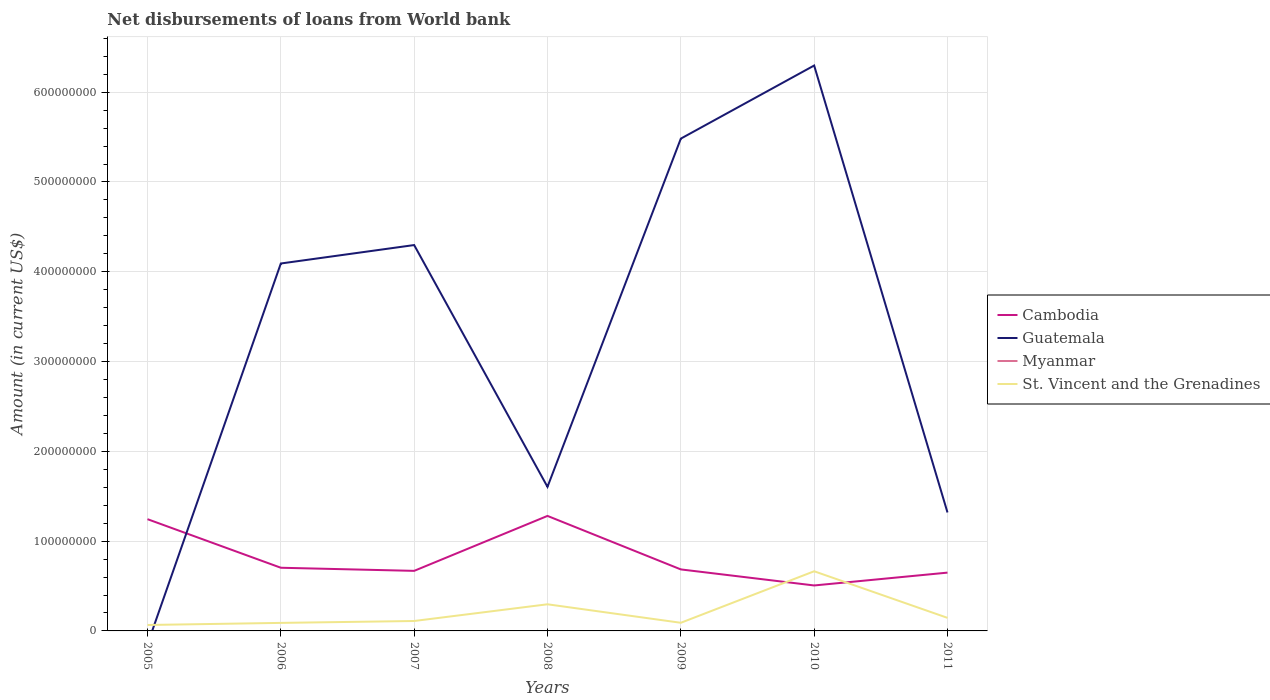How many different coloured lines are there?
Provide a short and direct response. 3. Does the line corresponding to Guatemala intersect with the line corresponding to Myanmar?
Provide a succinct answer. Yes. Across all years, what is the maximum amount of loan disbursed from World Bank in Guatemala?
Keep it short and to the point. 0. What is the total amount of loan disbursed from World Bank in Cambodia in the graph?
Provide a succinct answer. 5.95e+07. What is the difference between the highest and the second highest amount of loan disbursed from World Bank in Cambodia?
Your response must be concise. 7.75e+07. What is the difference between the highest and the lowest amount of loan disbursed from World Bank in St. Vincent and the Grenadines?
Your response must be concise. 2. Is the amount of loan disbursed from World Bank in Cambodia strictly greater than the amount of loan disbursed from World Bank in Myanmar over the years?
Your answer should be very brief. No. How many lines are there?
Your response must be concise. 3. How many years are there in the graph?
Your answer should be compact. 7. What is the difference between two consecutive major ticks on the Y-axis?
Offer a terse response. 1.00e+08. Are the values on the major ticks of Y-axis written in scientific E-notation?
Your response must be concise. No. Does the graph contain any zero values?
Offer a terse response. Yes. How many legend labels are there?
Make the answer very short. 4. What is the title of the graph?
Your answer should be very brief. Net disbursements of loans from World bank. What is the label or title of the Y-axis?
Your answer should be compact. Amount (in current US$). What is the Amount (in current US$) of Cambodia in 2005?
Give a very brief answer. 1.24e+08. What is the Amount (in current US$) in St. Vincent and the Grenadines in 2005?
Provide a short and direct response. 6.60e+06. What is the Amount (in current US$) of Cambodia in 2006?
Keep it short and to the point. 7.04e+07. What is the Amount (in current US$) in Guatemala in 2006?
Provide a short and direct response. 4.09e+08. What is the Amount (in current US$) of St. Vincent and the Grenadines in 2006?
Offer a very short reply. 8.95e+06. What is the Amount (in current US$) of Cambodia in 2007?
Give a very brief answer. 6.69e+07. What is the Amount (in current US$) in Guatemala in 2007?
Provide a succinct answer. 4.30e+08. What is the Amount (in current US$) in St. Vincent and the Grenadines in 2007?
Your response must be concise. 1.10e+07. What is the Amount (in current US$) in Cambodia in 2008?
Keep it short and to the point. 1.28e+08. What is the Amount (in current US$) of Guatemala in 2008?
Provide a succinct answer. 1.60e+08. What is the Amount (in current US$) of St. Vincent and the Grenadines in 2008?
Provide a short and direct response. 2.97e+07. What is the Amount (in current US$) of Cambodia in 2009?
Offer a very short reply. 6.85e+07. What is the Amount (in current US$) of Guatemala in 2009?
Keep it short and to the point. 5.48e+08. What is the Amount (in current US$) in St. Vincent and the Grenadines in 2009?
Provide a short and direct response. 9.07e+06. What is the Amount (in current US$) of Cambodia in 2010?
Your answer should be compact. 5.06e+07. What is the Amount (in current US$) of Guatemala in 2010?
Your answer should be compact. 6.30e+08. What is the Amount (in current US$) of St. Vincent and the Grenadines in 2010?
Give a very brief answer. 6.64e+07. What is the Amount (in current US$) of Cambodia in 2011?
Offer a terse response. 6.49e+07. What is the Amount (in current US$) in Guatemala in 2011?
Make the answer very short. 1.32e+08. What is the Amount (in current US$) of Myanmar in 2011?
Make the answer very short. 0. What is the Amount (in current US$) in St. Vincent and the Grenadines in 2011?
Provide a short and direct response. 1.46e+07. Across all years, what is the maximum Amount (in current US$) in Cambodia?
Provide a succinct answer. 1.28e+08. Across all years, what is the maximum Amount (in current US$) in Guatemala?
Ensure brevity in your answer.  6.30e+08. Across all years, what is the maximum Amount (in current US$) of St. Vincent and the Grenadines?
Ensure brevity in your answer.  6.64e+07. Across all years, what is the minimum Amount (in current US$) of Cambodia?
Give a very brief answer. 5.06e+07. Across all years, what is the minimum Amount (in current US$) in Guatemala?
Provide a short and direct response. 0. Across all years, what is the minimum Amount (in current US$) in St. Vincent and the Grenadines?
Your response must be concise. 6.60e+06. What is the total Amount (in current US$) of Cambodia in the graph?
Ensure brevity in your answer.  5.74e+08. What is the total Amount (in current US$) in Guatemala in the graph?
Make the answer very short. 2.31e+09. What is the total Amount (in current US$) in Myanmar in the graph?
Make the answer very short. 0. What is the total Amount (in current US$) in St. Vincent and the Grenadines in the graph?
Ensure brevity in your answer.  1.46e+08. What is the difference between the Amount (in current US$) of Cambodia in 2005 and that in 2006?
Offer a terse response. 5.41e+07. What is the difference between the Amount (in current US$) in St. Vincent and the Grenadines in 2005 and that in 2006?
Give a very brief answer. -2.34e+06. What is the difference between the Amount (in current US$) of Cambodia in 2005 and that in 2007?
Keep it short and to the point. 5.76e+07. What is the difference between the Amount (in current US$) of St. Vincent and the Grenadines in 2005 and that in 2007?
Your response must be concise. -4.44e+06. What is the difference between the Amount (in current US$) in Cambodia in 2005 and that in 2008?
Your answer should be very brief. -3.62e+06. What is the difference between the Amount (in current US$) of St. Vincent and the Grenadines in 2005 and that in 2008?
Ensure brevity in your answer.  -2.31e+07. What is the difference between the Amount (in current US$) in Cambodia in 2005 and that in 2009?
Provide a succinct answer. 5.60e+07. What is the difference between the Amount (in current US$) in St. Vincent and the Grenadines in 2005 and that in 2009?
Offer a very short reply. -2.46e+06. What is the difference between the Amount (in current US$) in Cambodia in 2005 and that in 2010?
Provide a short and direct response. 7.38e+07. What is the difference between the Amount (in current US$) in St. Vincent and the Grenadines in 2005 and that in 2010?
Give a very brief answer. -5.98e+07. What is the difference between the Amount (in current US$) in Cambodia in 2005 and that in 2011?
Your answer should be very brief. 5.95e+07. What is the difference between the Amount (in current US$) in St. Vincent and the Grenadines in 2005 and that in 2011?
Keep it short and to the point. -7.96e+06. What is the difference between the Amount (in current US$) in Cambodia in 2006 and that in 2007?
Your answer should be very brief. 3.47e+06. What is the difference between the Amount (in current US$) of Guatemala in 2006 and that in 2007?
Ensure brevity in your answer.  -2.05e+07. What is the difference between the Amount (in current US$) in St. Vincent and the Grenadines in 2006 and that in 2007?
Provide a short and direct response. -2.10e+06. What is the difference between the Amount (in current US$) of Cambodia in 2006 and that in 2008?
Keep it short and to the point. -5.77e+07. What is the difference between the Amount (in current US$) in Guatemala in 2006 and that in 2008?
Provide a succinct answer. 2.49e+08. What is the difference between the Amount (in current US$) in St. Vincent and the Grenadines in 2006 and that in 2008?
Offer a very short reply. -2.07e+07. What is the difference between the Amount (in current US$) of Cambodia in 2006 and that in 2009?
Provide a succinct answer. 1.87e+06. What is the difference between the Amount (in current US$) of Guatemala in 2006 and that in 2009?
Provide a succinct answer. -1.39e+08. What is the difference between the Amount (in current US$) in St. Vincent and the Grenadines in 2006 and that in 2009?
Give a very brief answer. -1.19e+05. What is the difference between the Amount (in current US$) of Cambodia in 2006 and that in 2010?
Make the answer very short. 1.97e+07. What is the difference between the Amount (in current US$) of Guatemala in 2006 and that in 2010?
Your response must be concise. -2.20e+08. What is the difference between the Amount (in current US$) of St. Vincent and the Grenadines in 2006 and that in 2010?
Your response must be concise. -5.75e+07. What is the difference between the Amount (in current US$) in Cambodia in 2006 and that in 2011?
Ensure brevity in your answer.  5.43e+06. What is the difference between the Amount (in current US$) in Guatemala in 2006 and that in 2011?
Your answer should be compact. 2.77e+08. What is the difference between the Amount (in current US$) of St. Vincent and the Grenadines in 2006 and that in 2011?
Give a very brief answer. -5.62e+06. What is the difference between the Amount (in current US$) of Cambodia in 2007 and that in 2008?
Provide a succinct answer. -6.12e+07. What is the difference between the Amount (in current US$) in Guatemala in 2007 and that in 2008?
Provide a short and direct response. 2.69e+08. What is the difference between the Amount (in current US$) of St. Vincent and the Grenadines in 2007 and that in 2008?
Offer a terse response. -1.86e+07. What is the difference between the Amount (in current US$) of Cambodia in 2007 and that in 2009?
Give a very brief answer. -1.60e+06. What is the difference between the Amount (in current US$) of Guatemala in 2007 and that in 2009?
Make the answer very short. -1.19e+08. What is the difference between the Amount (in current US$) of St. Vincent and the Grenadines in 2007 and that in 2009?
Offer a very short reply. 1.98e+06. What is the difference between the Amount (in current US$) in Cambodia in 2007 and that in 2010?
Give a very brief answer. 1.63e+07. What is the difference between the Amount (in current US$) of Guatemala in 2007 and that in 2010?
Give a very brief answer. -2.00e+08. What is the difference between the Amount (in current US$) of St. Vincent and the Grenadines in 2007 and that in 2010?
Your answer should be compact. -5.54e+07. What is the difference between the Amount (in current US$) of Cambodia in 2007 and that in 2011?
Make the answer very short. 1.97e+06. What is the difference between the Amount (in current US$) in Guatemala in 2007 and that in 2011?
Offer a terse response. 2.98e+08. What is the difference between the Amount (in current US$) of St. Vincent and the Grenadines in 2007 and that in 2011?
Your answer should be compact. -3.51e+06. What is the difference between the Amount (in current US$) in Cambodia in 2008 and that in 2009?
Your answer should be very brief. 5.96e+07. What is the difference between the Amount (in current US$) of Guatemala in 2008 and that in 2009?
Offer a very short reply. -3.88e+08. What is the difference between the Amount (in current US$) in St. Vincent and the Grenadines in 2008 and that in 2009?
Your response must be concise. 2.06e+07. What is the difference between the Amount (in current US$) in Cambodia in 2008 and that in 2010?
Give a very brief answer. 7.75e+07. What is the difference between the Amount (in current US$) of Guatemala in 2008 and that in 2010?
Give a very brief answer. -4.69e+08. What is the difference between the Amount (in current US$) in St. Vincent and the Grenadines in 2008 and that in 2010?
Your answer should be compact. -3.68e+07. What is the difference between the Amount (in current US$) in Cambodia in 2008 and that in 2011?
Give a very brief answer. 6.32e+07. What is the difference between the Amount (in current US$) of Guatemala in 2008 and that in 2011?
Give a very brief answer. 2.85e+07. What is the difference between the Amount (in current US$) of St. Vincent and the Grenadines in 2008 and that in 2011?
Provide a short and direct response. 1.51e+07. What is the difference between the Amount (in current US$) in Cambodia in 2009 and that in 2010?
Your response must be concise. 1.79e+07. What is the difference between the Amount (in current US$) in Guatemala in 2009 and that in 2010?
Your answer should be very brief. -8.14e+07. What is the difference between the Amount (in current US$) in St. Vincent and the Grenadines in 2009 and that in 2010?
Keep it short and to the point. -5.74e+07. What is the difference between the Amount (in current US$) of Cambodia in 2009 and that in 2011?
Provide a succinct answer. 3.57e+06. What is the difference between the Amount (in current US$) in Guatemala in 2009 and that in 2011?
Your response must be concise. 4.16e+08. What is the difference between the Amount (in current US$) in St. Vincent and the Grenadines in 2009 and that in 2011?
Keep it short and to the point. -5.50e+06. What is the difference between the Amount (in current US$) of Cambodia in 2010 and that in 2011?
Ensure brevity in your answer.  -1.43e+07. What is the difference between the Amount (in current US$) in Guatemala in 2010 and that in 2011?
Your response must be concise. 4.98e+08. What is the difference between the Amount (in current US$) of St. Vincent and the Grenadines in 2010 and that in 2011?
Give a very brief answer. 5.19e+07. What is the difference between the Amount (in current US$) in Cambodia in 2005 and the Amount (in current US$) in Guatemala in 2006?
Provide a short and direct response. -2.85e+08. What is the difference between the Amount (in current US$) of Cambodia in 2005 and the Amount (in current US$) of St. Vincent and the Grenadines in 2006?
Provide a succinct answer. 1.16e+08. What is the difference between the Amount (in current US$) in Cambodia in 2005 and the Amount (in current US$) in Guatemala in 2007?
Your answer should be compact. -3.05e+08. What is the difference between the Amount (in current US$) in Cambodia in 2005 and the Amount (in current US$) in St. Vincent and the Grenadines in 2007?
Provide a short and direct response. 1.13e+08. What is the difference between the Amount (in current US$) in Cambodia in 2005 and the Amount (in current US$) in Guatemala in 2008?
Provide a succinct answer. -3.60e+07. What is the difference between the Amount (in current US$) of Cambodia in 2005 and the Amount (in current US$) of St. Vincent and the Grenadines in 2008?
Your answer should be very brief. 9.48e+07. What is the difference between the Amount (in current US$) in Cambodia in 2005 and the Amount (in current US$) in Guatemala in 2009?
Provide a succinct answer. -4.24e+08. What is the difference between the Amount (in current US$) of Cambodia in 2005 and the Amount (in current US$) of St. Vincent and the Grenadines in 2009?
Your answer should be compact. 1.15e+08. What is the difference between the Amount (in current US$) of Cambodia in 2005 and the Amount (in current US$) of Guatemala in 2010?
Provide a succinct answer. -5.05e+08. What is the difference between the Amount (in current US$) of Cambodia in 2005 and the Amount (in current US$) of St. Vincent and the Grenadines in 2010?
Offer a very short reply. 5.80e+07. What is the difference between the Amount (in current US$) of Cambodia in 2005 and the Amount (in current US$) of Guatemala in 2011?
Offer a terse response. -7.47e+06. What is the difference between the Amount (in current US$) of Cambodia in 2005 and the Amount (in current US$) of St. Vincent and the Grenadines in 2011?
Keep it short and to the point. 1.10e+08. What is the difference between the Amount (in current US$) in Cambodia in 2006 and the Amount (in current US$) in Guatemala in 2007?
Offer a very short reply. -3.59e+08. What is the difference between the Amount (in current US$) of Cambodia in 2006 and the Amount (in current US$) of St. Vincent and the Grenadines in 2007?
Offer a very short reply. 5.93e+07. What is the difference between the Amount (in current US$) in Guatemala in 2006 and the Amount (in current US$) in St. Vincent and the Grenadines in 2007?
Your response must be concise. 3.98e+08. What is the difference between the Amount (in current US$) of Cambodia in 2006 and the Amount (in current US$) of Guatemala in 2008?
Your response must be concise. -9.01e+07. What is the difference between the Amount (in current US$) in Cambodia in 2006 and the Amount (in current US$) in St. Vincent and the Grenadines in 2008?
Your answer should be compact. 4.07e+07. What is the difference between the Amount (in current US$) of Guatemala in 2006 and the Amount (in current US$) of St. Vincent and the Grenadines in 2008?
Ensure brevity in your answer.  3.80e+08. What is the difference between the Amount (in current US$) in Cambodia in 2006 and the Amount (in current US$) in Guatemala in 2009?
Give a very brief answer. -4.78e+08. What is the difference between the Amount (in current US$) in Cambodia in 2006 and the Amount (in current US$) in St. Vincent and the Grenadines in 2009?
Provide a succinct answer. 6.13e+07. What is the difference between the Amount (in current US$) of Guatemala in 2006 and the Amount (in current US$) of St. Vincent and the Grenadines in 2009?
Provide a short and direct response. 4.00e+08. What is the difference between the Amount (in current US$) of Cambodia in 2006 and the Amount (in current US$) of Guatemala in 2010?
Provide a short and direct response. -5.59e+08. What is the difference between the Amount (in current US$) of Cambodia in 2006 and the Amount (in current US$) of St. Vincent and the Grenadines in 2010?
Your response must be concise. 3.92e+06. What is the difference between the Amount (in current US$) of Guatemala in 2006 and the Amount (in current US$) of St. Vincent and the Grenadines in 2010?
Your answer should be very brief. 3.43e+08. What is the difference between the Amount (in current US$) in Cambodia in 2006 and the Amount (in current US$) in Guatemala in 2011?
Provide a succinct answer. -6.16e+07. What is the difference between the Amount (in current US$) of Cambodia in 2006 and the Amount (in current US$) of St. Vincent and the Grenadines in 2011?
Make the answer very short. 5.58e+07. What is the difference between the Amount (in current US$) in Guatemala in 2006 and the Amount (in current US$) in St. Vincent and the Grenadines in 2011?
Make the answer very short. 3.95e+08. What is the difference between the Amount (in current US$) of Cambodia in 2007 and the Amount (in current US$) of Guatemala in 2008?
Make the answer very short. -9.36e+07. What is the difference between the Amount (in current US$) in Cambodia in 2007 and the Amount (in current US$) in St. Vincent and the Grenadines in 2008?
Your answer should be very brief. 3.72e+07. What is the difference between the Amount (in current US$) in Guatemala in 2007 and the Amount (in current US$) in St. Vincent and the Grenadines in 2008?
Your response must be concise. 4.00e+08. What is the difference between the Amount (in current US$) in Cambodia in 2007 and the Amount (in current US$) in Guatemala in 2009?
Ensure brevity in your answer.  -4.81e+08. What is the difference between the Amount (in current US$) of Cambodia in 2007 and the Amount (in current US$) of St. Vincent and the Grenadines in 2009?
Keep it short and to the point. 5.78e+07. What is the difference between the Amount (in current US$) in Guatemala in 2007 and the Amount (in current US$) in St. Vincent and the Grenadines in 2009?
Your response must be concise. 4.21e+08. What is the difference between the Amount (in current US$) of Cambodia in 2007 and the Amount (in current US$) of Guatemala in 2010?
Give a very brief answer. -5.63e+08. What is the difference between the Amount (in current US$) in Cambodia in 2007 and the Amount (in current US$) in St. Vincent and the Grenadines in 2010?
Offer a terse response. 4.58e+05. What is the difference between the Amount (in current US$) of Guatemala in 2007 and the Amount (in current US$) of St. Vincent and the Grenadines in 2010?
Your answer should be compact. 3.63e+08. What is the difference between the Amount (in current US$) of Cambodia in 2007 and the Amount (in current US$) of Guatemala in 2011?
Your response must be concise. -6.50e+07. What is the difference between the Amount (in current US$) in Cambodia in 2007 and the Amount (in current US$) in St. Vincent and the Grenadines in 2011?
Keep it short and to the point. 5.23e+07. What is the difference between the Amount (in current US$) of Guatemala in 2007 and the Amount (in current US$) of St. Vincent and the Grenadines in 2011?
Your answer should be compact. 4.15e+08. What is the difference between the Amount (in current US$) of Cambodia in 2008 and the Amount (in current US$) of Guatemala in 2009?
Your response must be concise. -4.20e+08. What is the difference between the Amount (in current US$) in Cambodia in 2008 and the Amount (in current US$) in St. Vincent and the Grenadines in 2009?
Offer a terse response. 1.19e+08. What is the difference between the Amount (in current US$) in Guatemala in 2008 and the Amount (in current US$) in St. Vincent and the Grenadines in 2009?
Make the answer very short. 1.51e+08. What is the difference between the Amount (in current US$) in Cambodia in 2008 and the Amount (in current US$) in Guatemala in 2010?
Provide a short and direct response. -5.02e+08. What is the difference between the Amount (in current US$) in Cambodia in 2008 and the Amount (in current US$) in St. Vincent and the Grenadines in 2010?
Your answer should be very brief. 6.16e+07. What is the difference between the Amount (in current US$) in Guatemala in 2008 and the Amount (in current US$) in St. Vincent and the Grenadines in 2010?
Offer a very short reply. 9.40e+07. What is the difference between the Amount (in current US$) in Cambodia in 2008 and the Amount (in current US$) in Guatemala in 2011?
Your response must be concise. -3.85e+06. What is the difference between the Amount (in current US$) of Cambodia in 2008 and the Amount (in current US$) of St. Vincent and the Grenadines in 2011?
Offer a terse response. 1.14e+08. What is the difference between the Amount (in current US$) of Guatemala in 2008 and the Amount (in current US$) of St. Vincent and the Grenadines in 2011?
Provide a short and direct response. 1.46e+08. What is the difference between the Amount (in current US$) of Cambodia in 2009 and the Amount (in current US$) of Guatemala in 2010?
Offer a very short reply. -5.61e+08. What is the difference between the Amount (in current US$) of Cambodia in 2009 and the Amount (in current US$) of St. Vincent and the Grenadines in 2010?
Ensure brevity in your answer.  2.06e+06. What is the difference between the Amount (in current US$) of Guatemala in 2009 and the Amount (in current US$) of St. Vincent and the Grenadines in 2010?
Offer a terse response. 4.82e+08. What is the difference between the Amount (in current US$) in Cambodia in 2009 and the Amount (in current US$) in Guatemala in 2011?
Offer a terse response. -6.34e+07. What is the difference between the Amount (in current US$) in Cambodia in 2009 and the Amount (in current US$) in St. Vincent and the Grenadines in 2011?
Ensure brevity in your answer.  5.39e+07. What is the difference between the Amount (in current US$) of Guatemala in 2009 and the Amount (in current US$) of St. Vincent and the Grenadines in 2011?
Offer a terse response. 5.34e+08. What is the difference between the Amount (in current US$) of Cambodia in 2010 and the Amount (in current US$) of Guatemala in 2011?
Your answer should be very brief. -8.13e+07. What is the difference between the Amount (in current US$) of Cambodia in 2010 and the Amount (in current US$) of St. Vincent and the Grenadines in 2011?
Make the answer very short. 3.61e+07. What is the difference between the Amount (in current US$) in Guatemala in 2010 and the Amount (in current US$) in St. Vincent and the Grenadines in 2011?
Your answer should be very brief. 6.15e+08. What is the average Amount (in current US$) of Cambodia per year?
Your answer should be very brief. 8.20e+07. What is the average Amount (in current US$) of Guatemala per year?
Provide a short and direct response. 3.30e+08. What is the average Amount (in current US$) of Myanmar per year?
Make the answer very short. 0. What is the average Amount (in current US$) of St. Vincent and the Grenadines per year?
Your response must be concise. 2.09e+07. In the year 2005, what is the difference between the Amount (in current US$) in Cambodia and Amount (in current US$) in St. Vincent and the Grenadines?
Offer a very short reply. 1.18e+08. In the year 2006, what is the difference between the Amount (in current US$) of Cambodia and Amount (in current US$) of Guatemala?
Ensure brevity in your answer.  -3.39e+08. In the year 2006, what is the difference between the Amount (in current US$) in Cambodia and Amount (in current US$) in St. Vincent and the Grenadines?
Give a very brief answer. 6.14e+07. In the year 2006, what is the difference between the Amount (in current US$) of Guatemala and Amount (in current US$) of St. Vincent and the Grenadines?
Your answer should be very brief. 4.00e+08. In the year 2007, what is the difference between the Amount (in current US$) in Cambodia and Amount (in current US$) in Guatemala?
Provide a succinct answer. -3.63e+08. In the year 2007, what is the difference between the Amount (in current US$) in Cambodia and Amount (in current US$) in St. Vincent and the Grenadines?
Provide a succinct answer. 5.58e+07. In the year 2007, what is the difference between the Amount (in current US$) of Guatemala and Amount (in current US$) of St. Vincent and the Grenadines?
Offer a terse response. 4.19e+08. In the year 2008, what is the difference between the Amount (in current US$) of Cambodia and Amount (in current US$) of Guatemala?
Give a very brief answer. -3.24e+07. In the year 2008, what is the difference between the Amount (in current US$) of Cambodia and Amount (in current US$) of St. Vincent and the Grenadines?
Ensure brevity in your answer.  9.84e+07. In the year 2008, what is the difference between the Amount (in current US$) in Guatemala and Amount (in current US$) in St. Vincent and the Grenadines?
Ensure brevity in your answer.  1.31e+08. In the year 2009, what is the difference between the Amount (in current US$) in Cambodia and Amount (in current US$) in Guatemala?
Your response must be concise. -4.80e+08. In the year 2009, what is the difference between the Amount (in current US$) of Cambodia and Amount (in current US$) of St. Vincent and the Grenadines?
Offer a very short reply. 5.94e+07. In the year 2009, what is the difference between the Amount (in current US$) in Guatemala and Amount (in current US$) in St. Vincent and the Grenadines?
Offer a terse response. 5.39e+08. In the year 2010, what is the difference between the Amount (in current US$) of Cambodia and Amount (in current US$) of Guatemala?
Make the answer very short. -5.79e+08. In the year 2010, what is the difference between the Amount (in current US$) in Cambodia and Amount (in current US$) in St. Vincent and the Grenadines?
Provide a succinct answer. -1.58e+07. In the year 2010, what is the difference between the Amount (in current US$) in Guatemala and Amount (in current US$) in St. Vincent and the Grenadines?
Your response must be concise. 5.63e+08. In the year 2011, what is the difference between the Amount (in current US$) of Cambodia and Amount (in current US$) of Guatemala?
Ensure brevity in your answer.  -6.70e+07. In the year 2011, what is the difference between the Amount (in current US$) of Cambodia and Amount (in current US$) of St. Vincent and the Grenadines?
Offer a very short reply. 5.04e+07. In the year 2011, what is the difference between the Amount (in current US$) in Guatemala and Amount (in current US$) in St. Vincent and the Grenadines?
Your answer should be very brief. 1.17e+08. What is the ratio of the Amount (in current US$) in Cambodia in 2005 to that in 2006?
Offer a terse response. 1.77. What is the ratio of the Amount (in current US$) of St. Vincent and the Grenadines in 2005 to that in 2006?
Provide a succinct answer. 0.74. What is the ratio of the Amount (in current US$) of Cambodia in 2005 to that in 2007?
Provide a succinct answer. 1.86. What is the ratio of the Amount (in current US$) of St. Vincent and the Grenadines in 2005 to that in 2007?
Your answer should be compact. 0.6. What is the ratio of the Amount (in current US$) of Cambodia in 2005 to that in 2008?
Your response must be concise. 0.97. What is the ratio of the Amount (in current US$) of St. Vincent and the Grenadines in 2005 to that in 2008?
Make the answer very short. 0.22. What is the ratio of the Amount (in current US$) of Cambodia in 2005 to that in 2009?
Provide a succinct answer. 1.82. What is the ratio of the Amount (in current US$) of St. Vincent and the Grenadines in 2005 to that in 2009?
Provide a short and direct response. 0.73. What is the ratio of the Amount (in current US$) in Cambodia in 2005 to that in 2010?
Your response must be concise. 2.46. What is the ratio of the Amount (in current US$) in St. Vincent and the Grenadines in 2005 to that in 2010?
Make the answer very short. 0.1. What is the ratio of the Amount (in current US$) in Cambodia in 2005 to that in 2011?
Offer a very short reply. 1.92. What is the ratio of the Amount (in current US$) of St. Vincent and the Grenadines in 2005 to that in 2011?
Your response must be concise. 0.45. What is the ratio of the Amount (in current US$) in Cambodia in 2006 to that in 2007?
Ensure brevity in your answer.  1.05. What is the ratio of the Amount (in current US$) of Guatemala in 2006 to that in 2007?
Your answer should be compact. 0.95. What is the ratio of the Amount (in current US$) of St. Vincent and the Grenadines in 2006 to that in 2007?
Make the answer very short. 0.81. What is the ratio of the Amount (in current US$) in Cambodia in 2006 to that in 2008?
Provide a short and direct response. 0.55. What is the ratio of the Amount (in current US$) of Guatemala in 2006 to that in 2008?
Your response must be concise. 2.55. What is the ratio of the Amount (in current US$) of St. Vincent and the Grenadines in 2006 to that in 2008?
Give a very brief answer. 0.3. What is the ratio of the Amount (in current US$) in Cambodia in 2006 to that in 2009?
Your answer should be very brief. 1.03. What is the ratio of the Amount (in current US$) in Guatemala in 2006 to that in 2009?
Give a very brief answer. 0.75. What is the ratio of the Amount (in current US$) of St. Vincent and the Grenadines in 2006 to that in 2009?
Your answer should be compact. 0.99. What is the ratio of the Amount (in current US$) of Cambodia in 2006 to that in 2010?
Your response must be concise. 1.39. What is the ratio of the Amount (in current US$) of Guatemala in 2006 to that in 2010?
Your response must be concise. 0.65. What is the ratio of the Amount (in current US$) of St. Vincent and the Grenadines in 2006 to that in 2010?
Your answer should be very brief. 0.13. What is the ratio of the Amount (in current US$) in Cambodia in 2006 to that in 2011?
Provide a succinct answer. 1.08. What is the ratio of the Amount (in current US$) in Guatemala in 2006 to that in 2011?
Make the answer very short. 3.1. What is the ratio of the Amount (in current US$) of St. Vincent and the Grenadines in 2006 to that in 2011?
Provide a succinct answer. 0.61. What is the ratio of the Amount (in current US$) in Cambodia in 2007 to that in 2008?
Provide a short and direct response. 0.52. What is the ratio of the Amount (in current US$) in Guatemala in 2007 to that in 2008?
Offer a very short reply. 2.68. What is the ratio of the Amount (in current US$) in St. Vincent and the Grenadines in 2007 to that in 2008?
Provide a succinct answer. 0.37. What is the ratio of the Amount (in current US$) of Cambodia in 2007 to that in 2009?
Make the answer very short. 0.98. What is the ratio of the Amount (in current US$) in Guatemala in 2007 to that in 2009?
Your response must be concise. 0.78. What is the ratio of the Amount (in current US$) in St. Vincent and the Grenadines in 2007 to that in 2009?
Offer a very short reply. 1.22. What is the ratio of the Amount (in current US$) in Cambodia in 2007 to that in 2010?
Your response must be concise. 1.32. What is the ratio of the Amount (in current US$) of Guatemala in 2007 to that in 2010?
Offer a terse response. 0.68. What is the ratio of the Amount (in current US$) of St. Vincent and the Grenadines in 2007 to that in 2010?
Keep it short and to the point. 0.17. What is the ratio of the Amount (in current US$) in Cambodia in 2007 to that in 2011?
Offer a very short reply. 1.03. What is the ratio of the Amount (in current US$) of Guatemala in 2007 to that in 2011?
Your answer should be very brief. 3.26. What is the ratio of the Amount (in current US$) in St. Vincent and the Grenadines in 2007 to that in 2011?
Your answer should be compact. 0.76. What is the ratio of the Amount (in current US$) of Cambodia in 2008 to that in 2009?
Provide a short and direct response. 1.87. What is the ratio of the Amount (in current US$) of Guatemala in 2008 to that in 2009?
Your response must be concise. 0.29. What is the ratio of the Amount (in current US$) in St. Vincent and the Grenadines in 2008 to that in 2009?
Offer a very short reply. 3.27. What is the ratio of the Amount (in current US$) of Cambodia in 2008 to that in 2010?
Keep it short and to the point. 2.53. What is the ratio of the Amount (in current US$) of Guatemala in 2008 to that in 2010?
Give a very brief answer. 0.25. What is the ratio of the Amount (in current US$) in St. Vincent and the Grenadines in 2008 to that in 2010?
Provide a succinct answer. 0.45. What is the ratio of the Amount (in current US$) in Cambodia in 2008 to that in 2011?
Provide a short and direct response. 1.97. What is the ratio of the Amount (in current US$) in Guatemala in 2008 to that in 2011?
Give a very brief answer. 1.22. What is the ratio of the Amount (in current US$) of St. Vincent and the Grenadines in 2008 to that in 2011?
Give a very brief answer. 2.04. What is the ratio of the Amount (in current US$) of Cambodia in 2009 to that in 2010?
Ensure brevity in your answer.  1.35. What is the ratio of the Amount (in current US$) in Guatemala in 2009 to that in 2010?
Offer a terse response. 0.87. What is the ratio of the Amount (in current US$) in St. Vincent and the Grenadines in 2009 to that in 2010?
Provide a succinct answer. 0.14. What is the ratio of the Amount (in current US$) of Cambodia in 2009 to that in 2011?
Keep it short and to the point. 1.05. What is the ratio of the Amount (in current US$) in Guatemala in 2009 to that in 2011?
Keep it short and to the point. 4.16. What is the ratio of the Amount (in current US$) of St. Vincent and the Grenadines in 2009 to that in 2011?
Give a very brief answer. 0.62. What is the ratio of the Amount (in current US$) in Cambodia in 2010 to that in 2011?
Give a very brief answer. 0.78. What is the ratio of the Amount (in current US$) of Guatemala in 2010 to that in 2011?
Provide a short and direct response. 4.77. What is the ratio of the Amount (in current US$) of St. Vincent and the Grenadines in 2010 to that in 2011?
Your answer should be very brief. 4.56. What is the difference between the highest and the second highest Amount (in current US$) in Cambodia?
Offer a very short reply. 3.62e+06. What is the difference between the highest and the second highest Amount (in current US$) in Guatemala?
Your answer should be very brief. 8.14e+07. What is the difference between the highest and the second highest Amount (in current US$) of St. Vincent and the Grenadines?
Your response must be concise. 3.68e+07. What is the difference between the highest and the lowest Amount (in current US$) in Cambodia?
Keep it short and to the point. 7.75e+07. What is the difference between the highest and the lowest Amount (in current US$) of Guatemala?
Your answer should be compact. 6.30e+08. What is the difference between the highest and the lowest Amount (in current US$) of St. Vincent and the Grenadines?
Your response must be concise. 5.98e+07. 